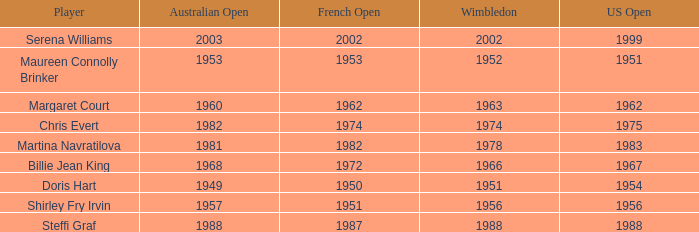When did Shirley Fry Irvin win the US Open? 1956.0. Can you parse all the data within this table? {'header': ['Player', 'Australian Open', 'French Open', 'Wimbledon', 'US Open'], 'rows': [['Serena Williams', '2003', '2002', '2002', '1999'], ['Maureen Connolly Brinker', '1953', '1953', '1952', '1951'], ['Margaret Court', '1960', '1962', '1963', '1962'], ['Chris Evert', '1982', '1974', '1974', '1975'], ['Martina Navratilova', '1981', '1982', '1978', '1983'], ['Billie Jean King', '1968', '1972', '1966', '1967'], ['Doris Hart', '1949', '1950', '1951', '1954'], ['Shirley Fry Irvin', '1957', '1951', '1956', '1956'], ['Steffi Graf', '1988', '1987', '1988', '1988']]} 